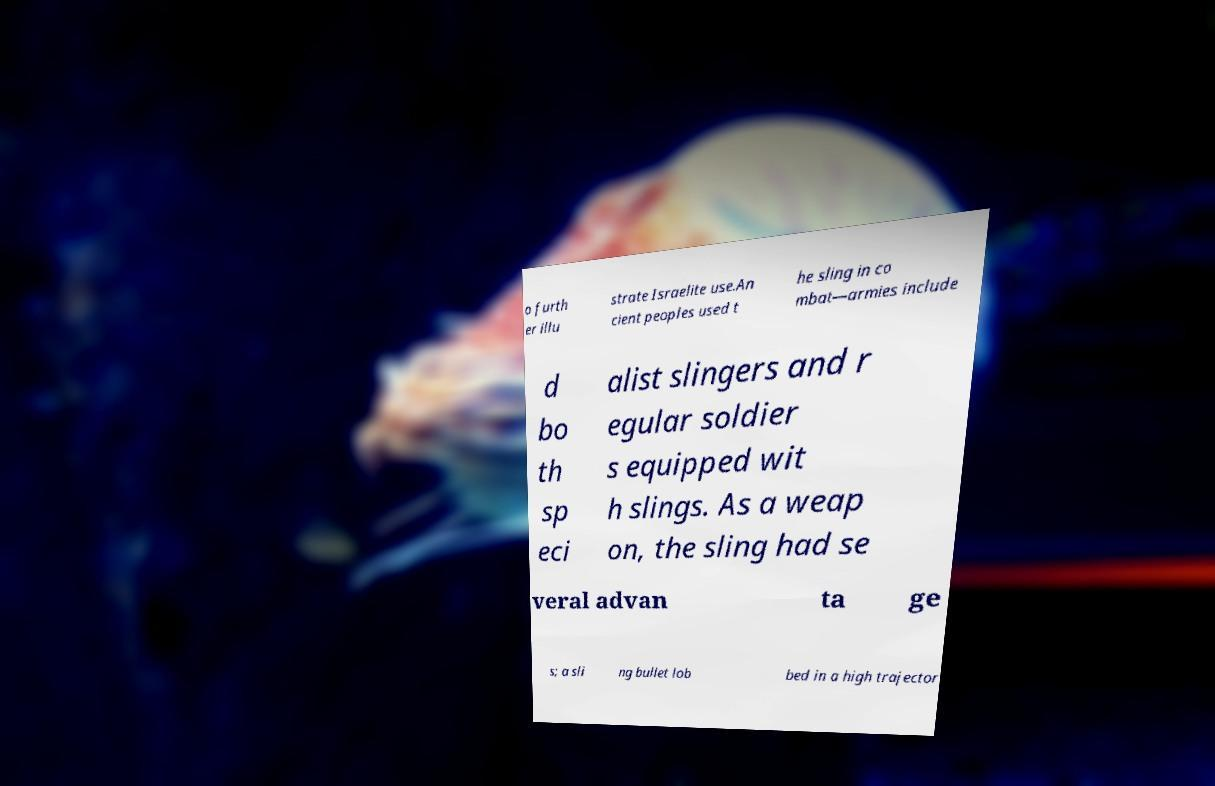For documentation purposes, I need the text within this image transcribed. Could you provide that? o furth er illu strate Israelite use.An cient peoples used t he sling in co mbat—armies include d bo th sp eci alist slingers and r egular soldier s equipped wit h slings. As a weap on, the sling had se veral advan ta ge s; a sli ng bullet lob bed in a high trajector 